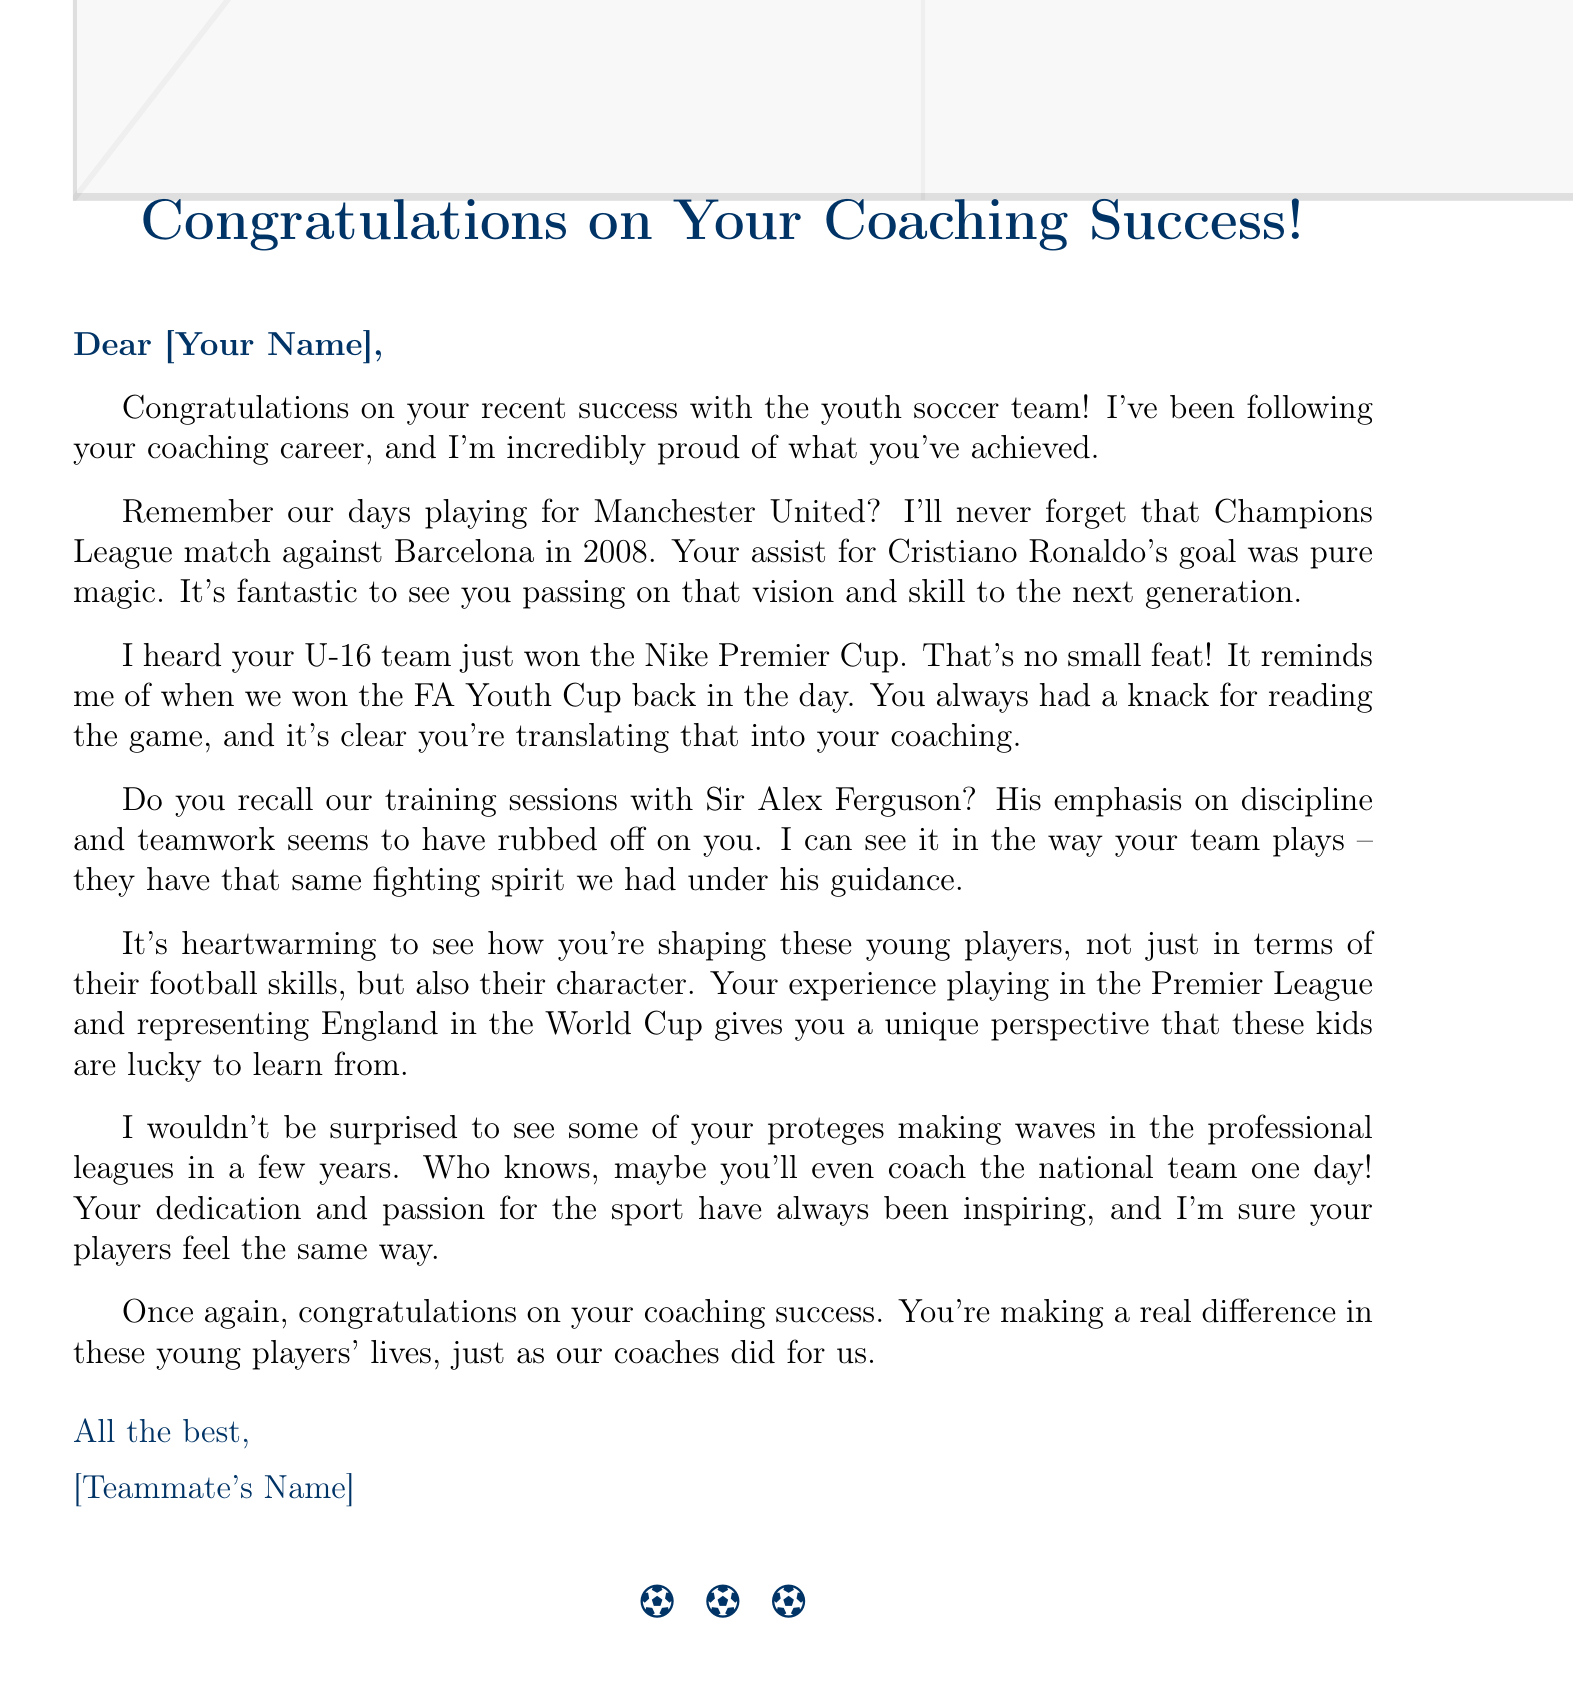What team did you coach? The letter mentions the U-16 team that won the Nike Premier Cup, indicating it was the youth team coached by the recipient.
Answer: U-16 team Who is congratulating you in the letter? The greeting and sign-off of the letter reveal that a former teammate is congratulating the recipient.
Answer: [Teammate's Name] What competition did your U-16 team win? The letter directly states the achievement of the U-16 team winning a specific competition, the Nike Premier Cup.
Answer: Nike Premier Cup Which famous player is mentioned in the nostalgic anecdote? The letter recalls a memorable match and specifically mentions a well-known player from that match, which points to the individual's achievement.
Answer: Cristiano Ronaldo What significant event is referenced to emphasize your coaching style? The letter reminisces about training sessions with a notable coach, highlighting the influence on the recipient's coaching style and approach.
Answer: Sir Alex Ferguson What does the letter indicate about the impact you have on the youth? The body of the letter highlights how the recipient shapes young players in not just soccer skills but also character, reflecting the broader impact of coaching.
Answer: Character What does the letter express regarding future possibilities for your proteges? The letter speculates that some of your players may find success in professional soccer, indicating the expectations of the recipients' coaching influence.
Answer: Professional leagues What was the tone of the letter? The combination of congratulatory remarks, nostalgic memories, and future wishes creates a warm and supportive tone throughout the letter.
Answer: Supportive 